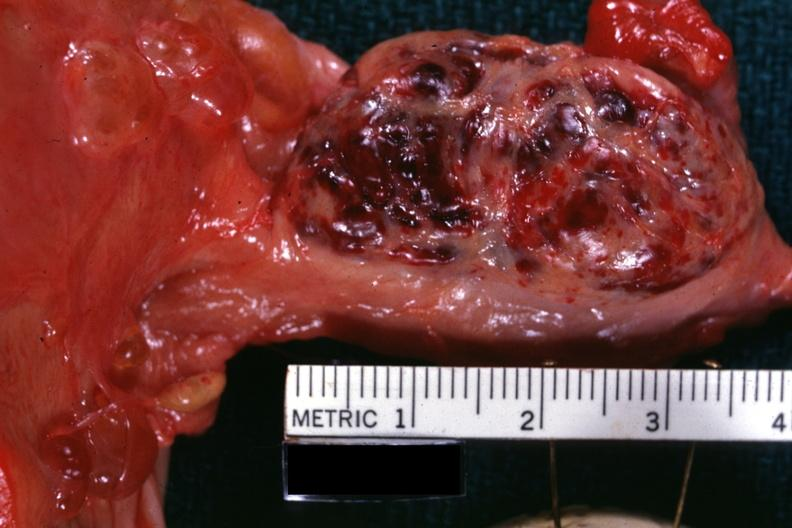s hemorrhagic corpus luteum present?
Answer the question using a single word or phrase. Yes 